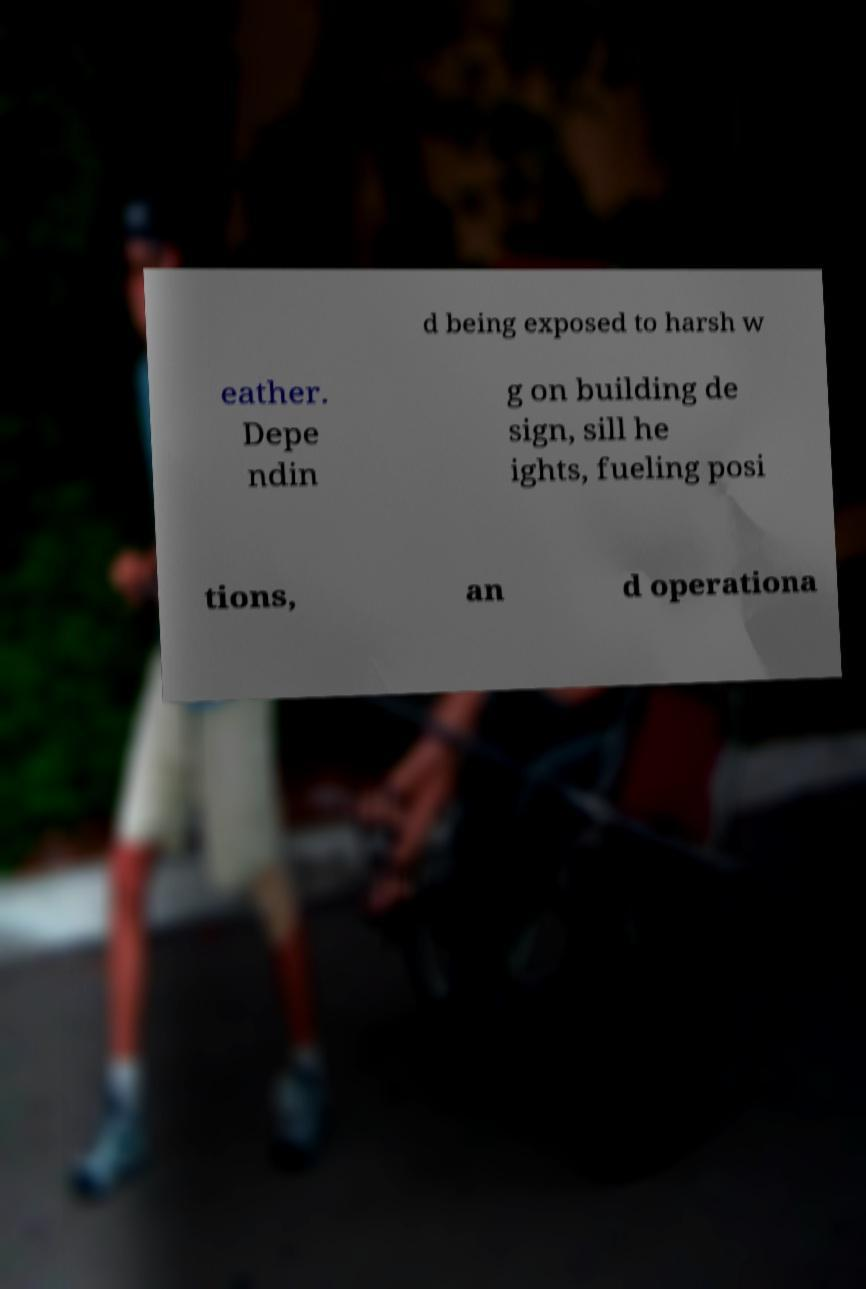Could you assist in decoding the text presented in this image and type it out clearly? d being exposed to harsh w eather. Depe ndin g on building de sign, sill he ights, fueling posi tions, an d operationa 